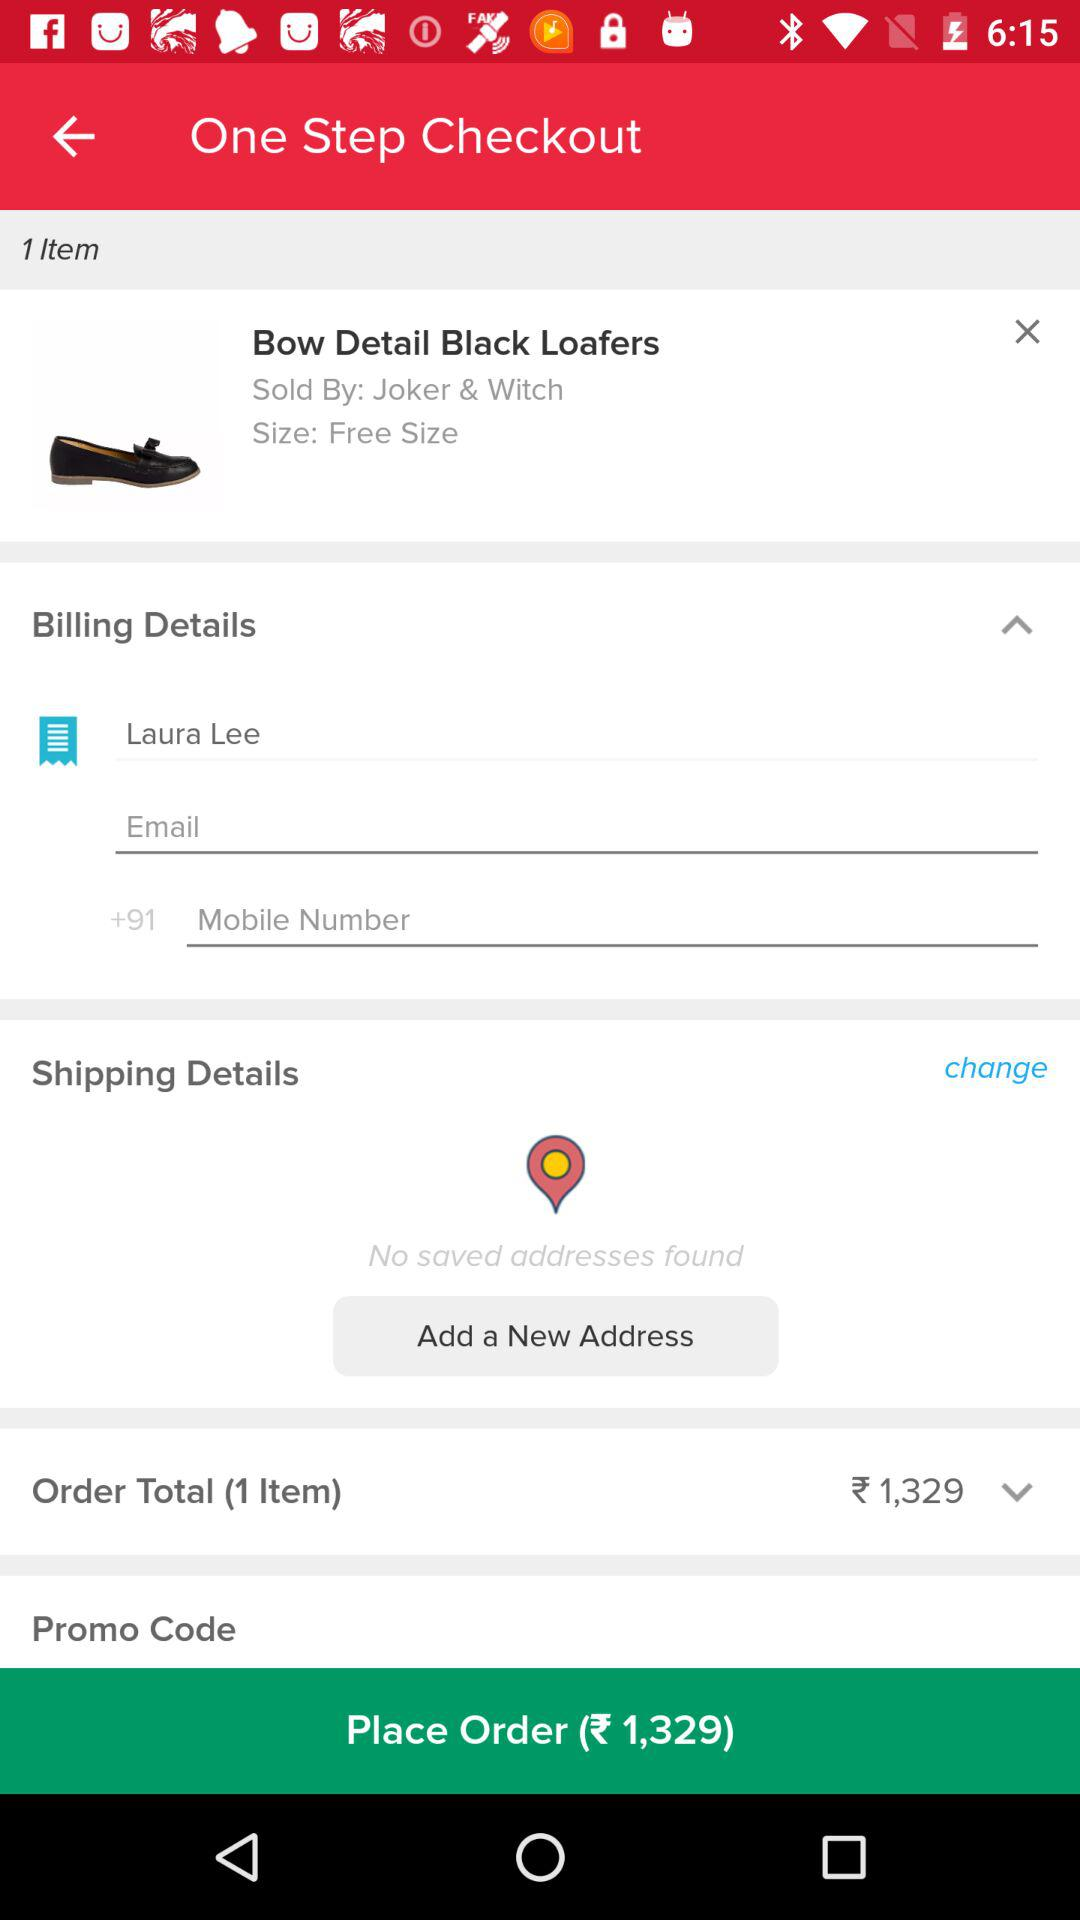How many items are in the order?
Answer the question using a single word or phrase. 1 